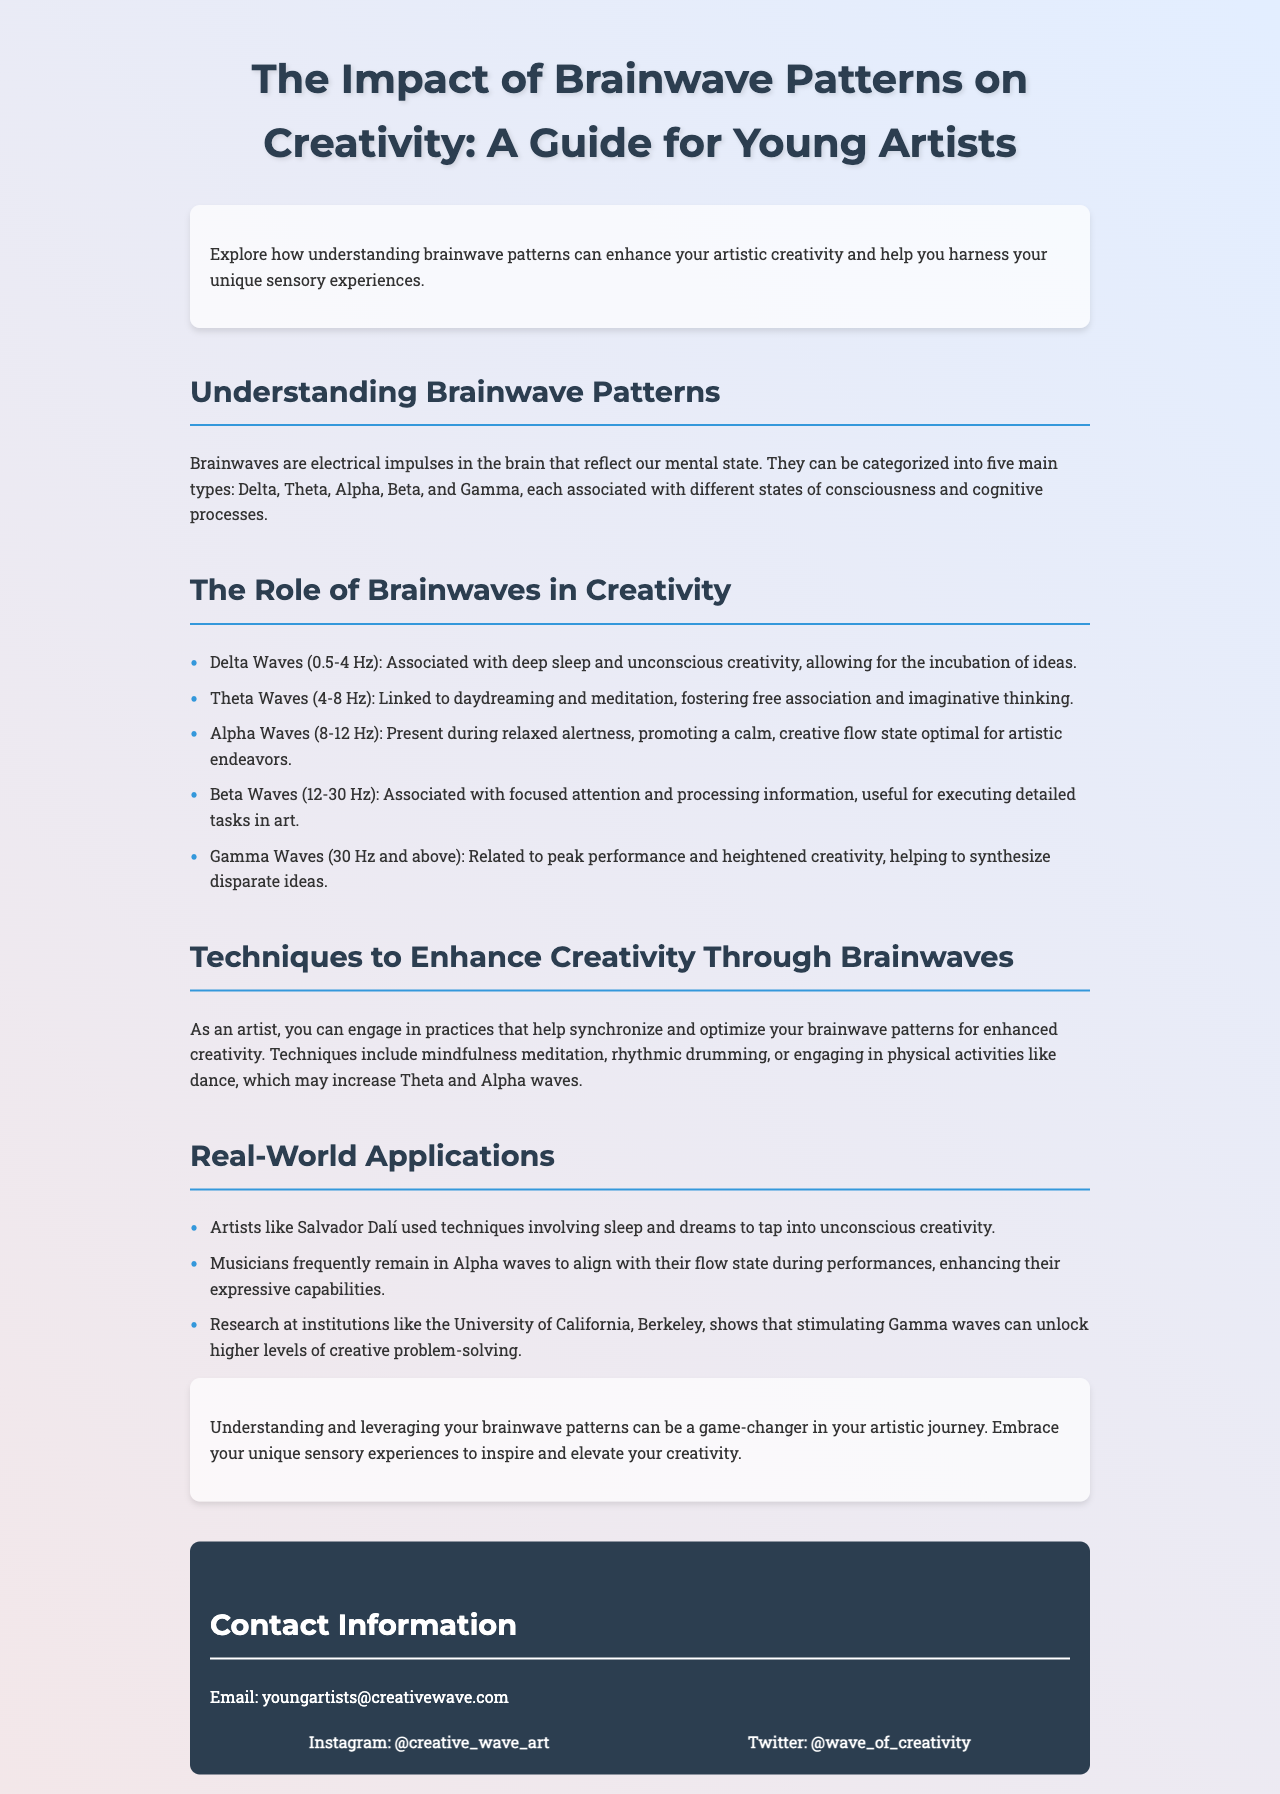What are the five main types of brainwaves? The document lists the five main types of brainwaves as Delta, Theta, Alpha, Beta, and Gamma.
Answer: Delta, Theta, Alpha, Beta, Gamma What brainwave type is associated with deep sleep? The document specifies that Delta waves are associated with deep sleep.
Answer: Delta Waves Which brainwave frequency is linked to daydreaming? The document states that Theta waves (4-8 Hz) are linked to daydreaming.
Answer: Theta Waves What technique is suggested to enhance creativity? The document suggests mindfulness meditation as a technique to enhance creativity.
Answer: Mindfulness meditation Who is mentioned as using sleep techniques for creativity? The document mentions Salvador Dalí as an artist who used sleep techniques to tap into creativity.
Answer: Salvador Dalí What brainwave type is dominant during relaxed alertness? The document indicates that Alpha waves are present during relaxed alertness.
Answer: Alpha Waves Which university is noted for research on Gamma waves? The document references the University of California, Berkeley, for research on stimulating Gamma waves.
Answer: University of California, Berkeley How do physical activities like dance affect brainwaves? The document explains that engaging in physical activities may increase Theta and Alpha waves.
Answer: Increase Theta and Alpha waves What is the primary focus of this brochure? The brochure primarily focuses on the impact of brainwave patterns on creativity for young artists.
Answer: Impact of brainwave patterns on creativity 